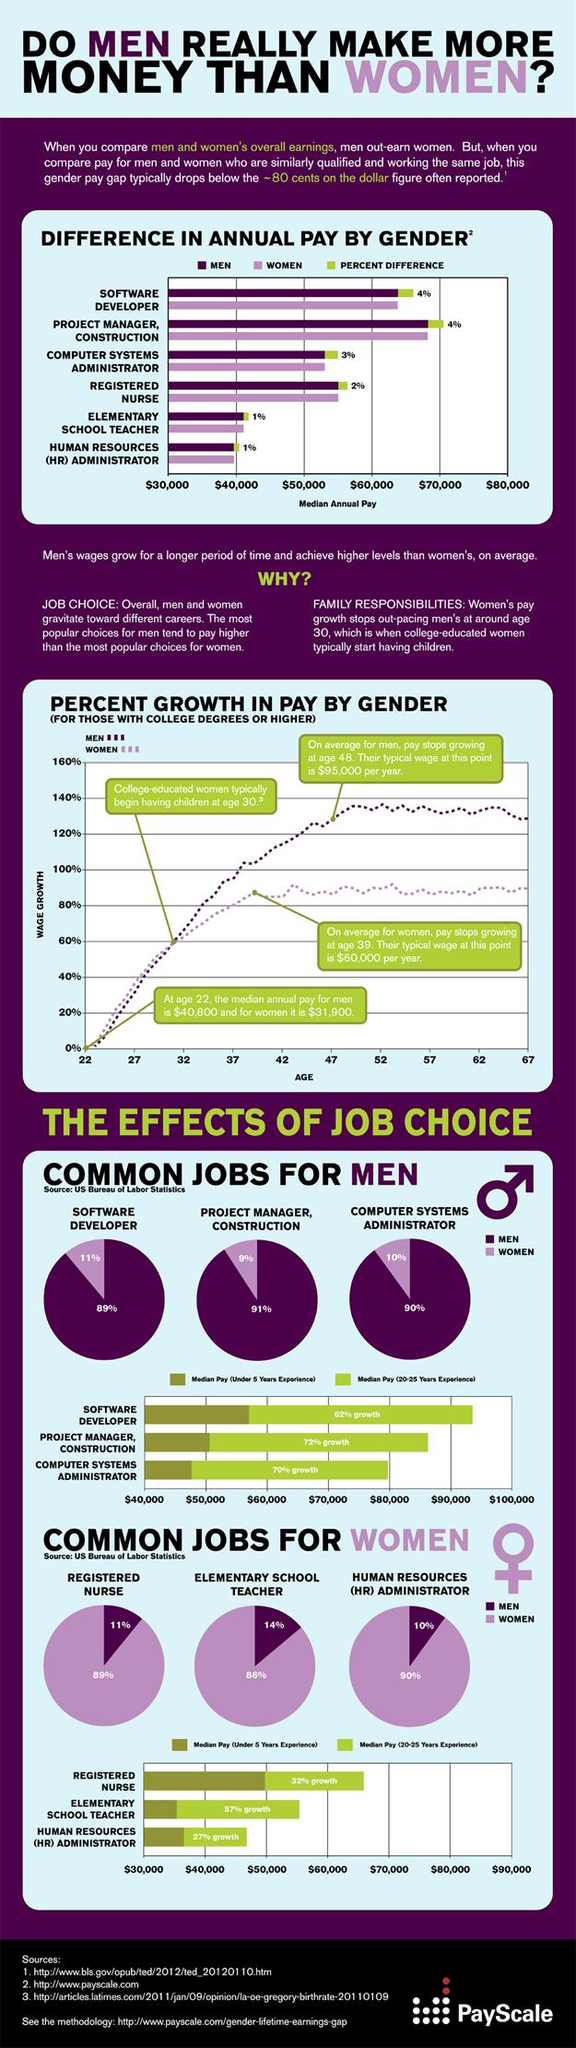Specify some key components in this picture. The median pay a project manager would receive if they have less than five years of experience is $51,000. The pay difference between men and women during the initial stage of their careers is approximately $8,900. The median pay for certain roles is more than $40,000, with Registered Nurses among them. The median annual pay of women has increased by $28,100 in 17 years. According to data, the pay difference between male and female nurses is approximately $2,000 per year. 